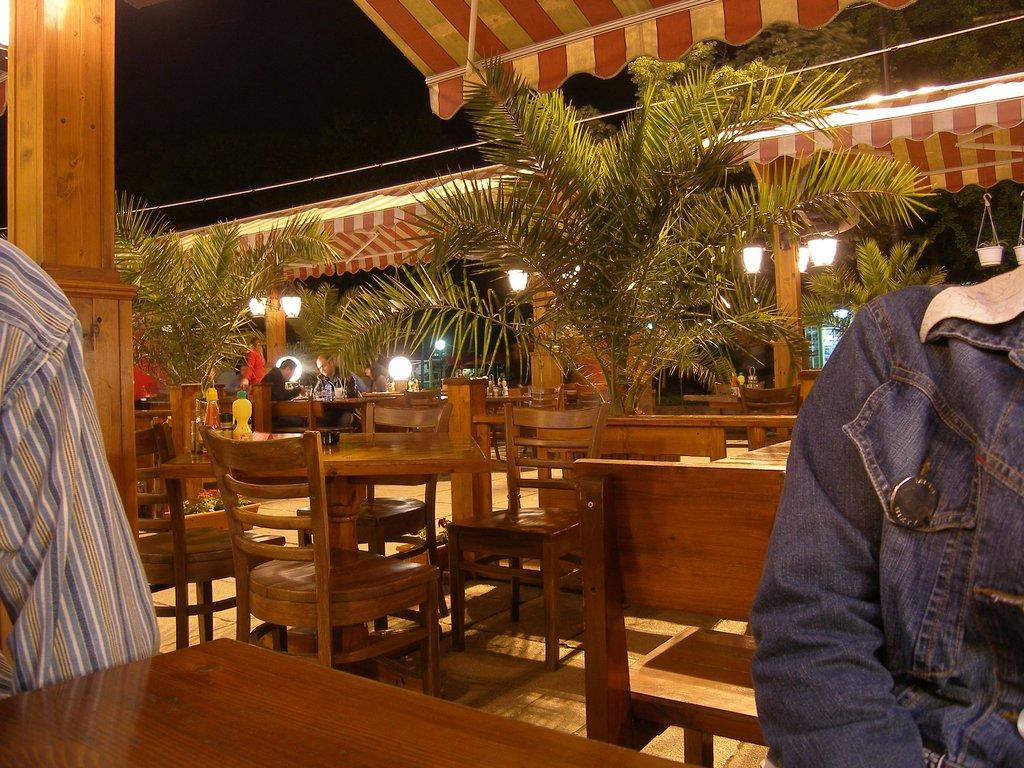What type of furniture is present in the image? There are chairs and tables in the image. What is placed between the chairs and tables? There are plants between the chairs and tables. How many people are sitting in the chairs? Two people are sitting on the chairs. How many children are playing with cars on the tables in the image? There are no children or cars present on the tables in the image. 